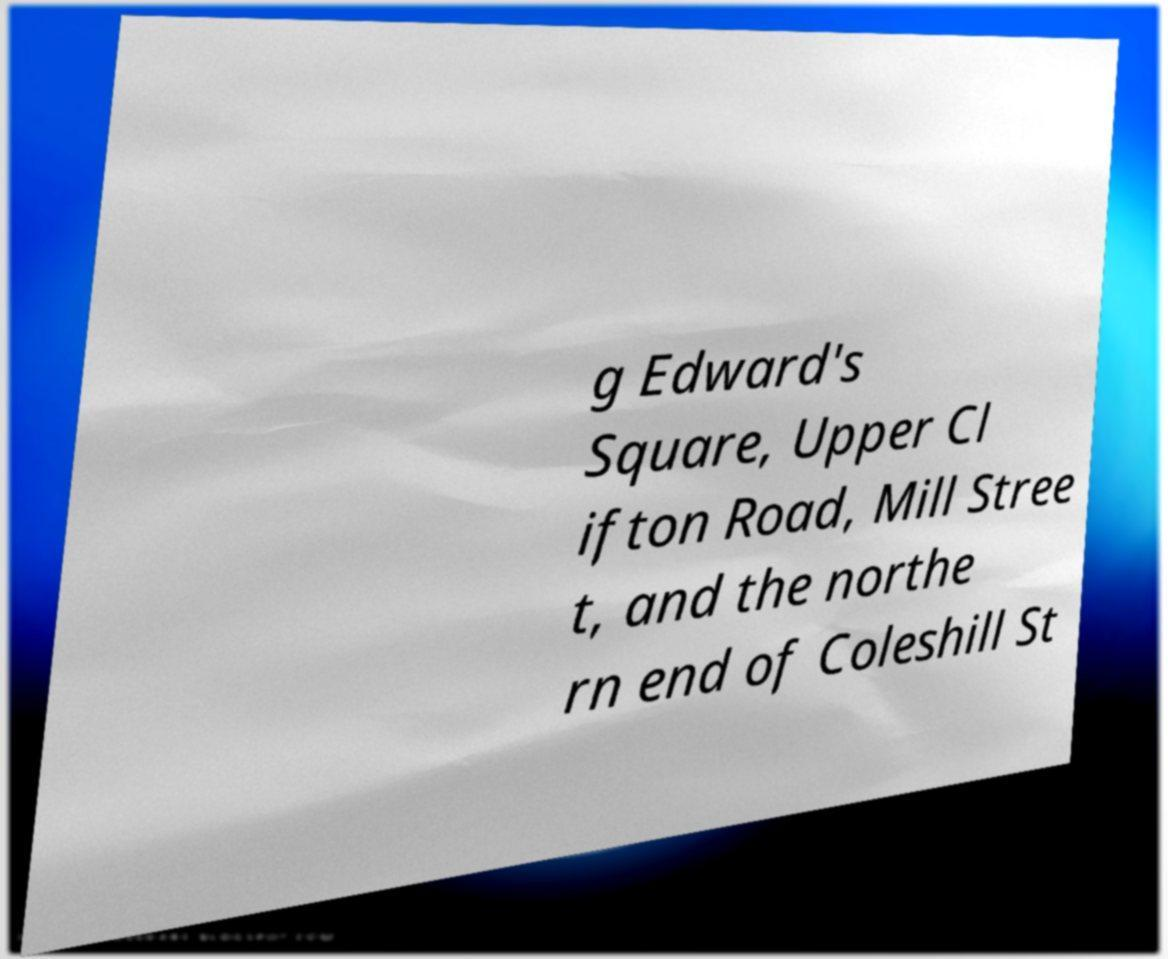Could you extract and type out the text from this image? g Edward's Square, Upper Cl ifton Road, Mill Stree t, and the northe rn end of Coleshill St 